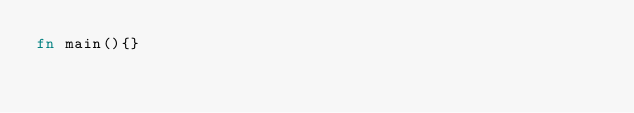<code> <loc_0><loc_0><loc_500><loc_500><_Rust_>fn main(){}</code> 